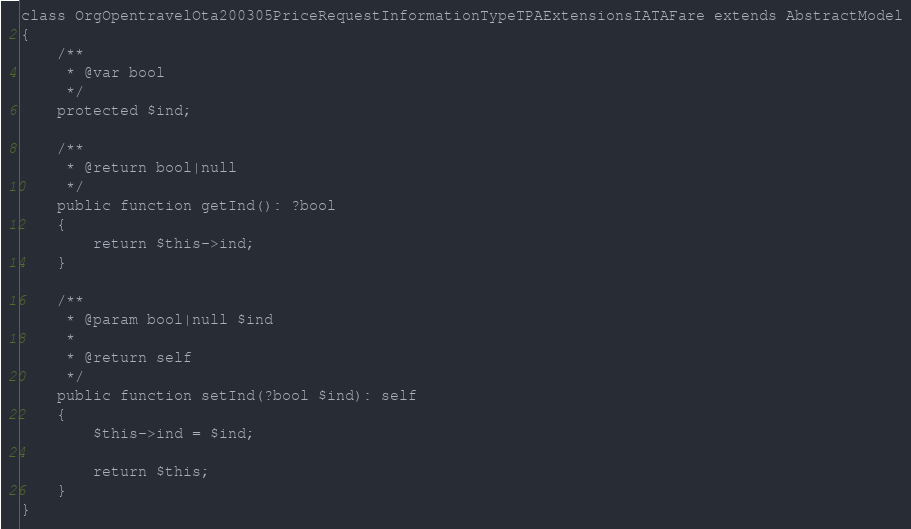<code> <loc_0><loc_0><loc_500><loc_500><_PHP_>class OrgOpentravelOta200305PriceRequestInformationTypeTPAExtensionsIATAFare extends AbstractModel
{
    /**
     * @var bool
     */
    protected $ind;

    /**
     * @return bool|null
     */
    public function getInd(): ?bool
    {
        return $this->ind;
    }

    /**
     * @param bool|null $ind
     *
     * @return self
     */
    public function setInd(?bool $ind): self
    {
        $this->ind = $ind;

        return $this;
    }
}
</code> 